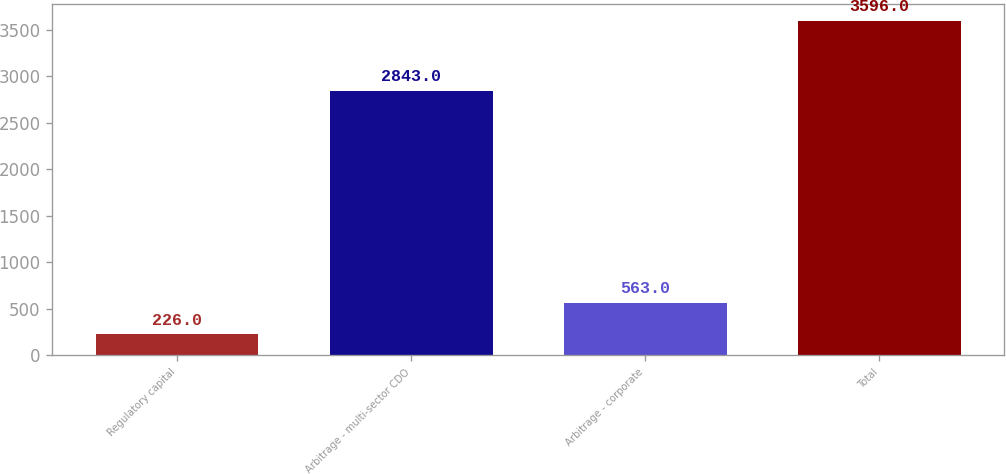Convert chart. <chart><loc_0><loc_0><loc_500><loc_500><bar_chart><fcel>Regulatory capital<fcel>Arbitrage - multi-sector CDO<fcel>Arbitrage - corporate<fcel>Total<nl><fcel>226<fcel>2843<fcel>563<fcel>3596<nl></chart> 